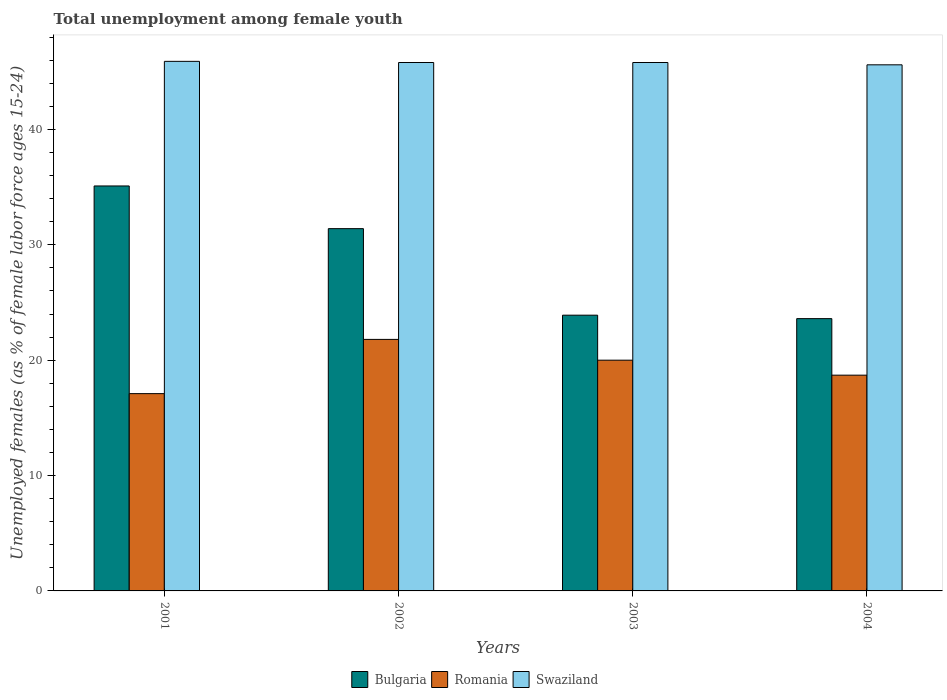How many different coloured bars are there?
Your answer should be very brief. 3. Are the number of bars per tick equal to the number of legend labels?
Offer a terse response. Yes. Are the number of bars on each tick of the X-axis equal?
Make the answer very short. Yes. How many bars are there on the 2nd tick from the left?
Your answer should be very brief. 3. How many bars are there on the 4th tick from the right?
Offer a terse response. 3. In how many cases, is the number of bars for a given year not equal to the number of legend labels?
Make the answer very short. 0. What is the percentage of unemployed females in in Swaziland in 2003?
Your response must be concise. 45.8. Across all years, what is the maximum percentage of unemployed females in in Swaziland?
Keep it short and to the point. 45.9. Across all years, what is the minimum percentage of unemployed females in in Romania?
Your answer should be compact. 17.1. In which year was the percentage of unemployed females in in Bulgaria minimum?
Make the answer very short. 2004. What is the total percentage of unemployed females in in Romania in the graph?
Keep it short and to the point. 77.6. What is the difference between the percentage of unemployed females in in Romania in 2003 and the percentage of unemployed females in in Swaziland in 2001?
Your response must be concise. -25.9. What is the average percentage of unemployed females in in Swaziland per year?
Your answer should be very brief. 45.77. In the year 2004, what is the difference between the percentage of unemployed females in in Swaziland and percentage of unemployed females in in Romania?
Give a very brief answer. 26.9. What is the ratio of the percentage of unemployed females in in Romania in 2001 to that in 2004?
Your response must be concise. 0.91. Is the percentage of unemployed females in in Romania in 2002 less than that in 2004?
Offer a very short reply. No. Is the difference between the percentage of unemployed females in in Swaziland in 2003 and 2004 greater than the difference between the percentage of unemployed females in in Romania in 2003 and 2004?
Provide a succinct answer. No. What is the difference between the highest and the second highest percentage of unemployed females in in Romania?
Give a very brief answer. 1.8. What is the difference between the highest and the lowest percentage of unemployed females in in Bulgaria?
Keep it short and to the point. 11.5. What does the 2nd bar from the left in 2003 represents?
Your response must be concise. Romania. What does the 3rd bar from the right in 2003 represents?
Provide a succinct answer. Bulgaria. Is it the case that in every year, the sum of the percentage of unemployed females in in Swaziland and percentage of unemployed females in in Romania is greater than the percentage of unemployed females in in Bulgaria?
Provide a short and direct response. Yes. How many bars are there?
Your response must be concise. 12. How many years are there in the graph?
Give a very brief answer. 4. Does the graph contain any zero values?
Your answer should be compact. No. Does the graph contain grids?
Make the answer very short. No. How many legend labels are there?
Provide a short and direct response. 3. What is the title of the graph?
Provide a succinct answer. Total unemployment among female youth. What is the label or title of the X-axis?
Offer a terse response. Years. What is the label or title of the Y-axis?
Make the answer very short. Unemployed females (as % of female labor force ages 15-24). What is the Unemployed females (as % of female labor force ages 15-24) of Bulgaria in 2001?
Keep it short and to the point. 35.1. What is the Unemployed females (as % of female labor force ages 15-24) of Romania in 2001?
Give a very brief answer. 17.1. What is the Unemployed females (as % of female labor force ages 15-24) in Swaziland in 2001?
Give a very brief answer. 45.9. What is the Unemployed females (as % of female labor force ages 15-24) of Bulgaria in 2002?
Make the answer very short. 31.4. What is the Unemployed females (as % of female labor force ages 15-24) of Romania in 2002?
Your answer should be very brief. 21.8. What is the Unemployed females (as % of female labor force ages 15-24) of Swaziland in 2002?
Ensure brevity in your answer.  45.8. What is the Unemployed females (as % of female labor force ages 15-24) in Bulgaria in 2003?
Your response must be concise. 23.9. What is the Unemployed females (as % of female labor force ages 15-24) of Swaziland in 2003?
Your response must be concise. 45.8. What is the Unemployed females (as % of female labor force ages 15-24) in Bulgaria in 2004?
Offer a very short reply. 23.6. What is the Unemployed females (as % of female labor force ages 15-24) of Romania in 2004?
Offer a very short reply. 18.7. What is the Unemployed females (as % of female labor force ages 15-24) of Swaziland in 2004?
Provide a succinct answer. 45.6. Across all years, what is the maximum Unemployed females (as % of female labor force ages 15-24) in Bulgaria?
Provide a short and direct response. 35.1. Across all years, what is the maximum Unemployed females (as % of female labor force ages 15-24) of Romania?
Provide a succinct answer. 21.8. Across all years, what is the maximum Unemployed females (as % of female labor force ages 15-24) in Swaziland?
Make the answer very short. 45.9. Across all years, what is the minimum Unemployed females (as % of female labor force ages 15-24) of Bulgaria?
Make the answer very short. 23.6. Across all years, what is the minimum Unemployed females (as % of female labor force ages 15-24) in Romania?
Provide a short and direct response. 17.1. Across all years, what is the minimum Unemployed females (as % of female labor force ages 15-24) in Swaziland?
Make the answer very short. 45.6. What is the total Unemployed females (as % of female labor force ages 15-24) of Bulgaria in the graph?
Offer a very short reply. 114. What is the total Unemployed females (as % of female labor force ages 15-24) in Romania in the graph?
Keep it short and to the point. 77.6. What is the total Unemployed females (as % of female labor force ages 15-24) of Swaziland in the graph?
Your response must be concise. 183.1. What is the difference between the Unemployed females (as % of female labor force ages 15-24) in Bulgaria in 2001 and that in 2002?
Provide a short and direct response. 3.7. What is the difference between the Unemployed females (as % of female labor force ages 15-24) of Romania in 2001 and that in 2002?
Your answer should be compact. -4.7. What is the difference between the Unemployed females (as % of female labor force ages 15-24) of Romania in 2001 and that in 2003?
Your response must be concise. -2.9. What is the difference between the Unemployed females (as % of female labor force ages 15-24) of Bulgaria in 2001 and that in 2004?
Give a very brief answer. 11.5. What is the difference between the Unemployed females (as % of female labor force ages 15-24) in Romania in 2001 and that in 2004?
Your response must be concise. -1.6. What is the difference between the Unemployed females (as % of female labor force ages 15-24) of Swaziland in 2002 and that in 2003?
Your answer should be compact. 0. What is the difference between the Unemployed females (as % of female labor force ages 15-24) of Bulgaria in 2002 and that in 2004?
Ensure brevity in your answer.  7.8. What is the difference between the Unemployed females (as % of female labor force ages 15-24) of Bulgaria in 2003 and that in 2004?
Give a very brief answer. 0.3. What is the difference between the Unemployed females (as % of female labor force ages 15-24) in Romania in 2001 and the Unemployed females (as % of female labor force ages 15-24) in Swaziland in 2002?
Your answer should be very brief. -28.7. What is the difference between the Unemployed females (as % of female labor force ages 15-24) in Bulgaria in 2001 and the Unemployed females (as % of female labor force ages 15-24) in Romania in 2003?
Your answer should be very brief. 15.1. What is the difference between the Unemployed females (as % of female labor force ages 15-24) in Bulgaria in 2001 and the Unemployed females (as % of female labor force ages 15-24) in Swaziland in 2003?
Your answer should be compact. -10.7. What is the difference between the Unemployed females (as % of female labor force ages 15-24) of Romania in 2001 and the Unemployed females (as % of female labor force ages 15-24) of Swaziland in 2003?
Your answer should be very brief. -28.7. What is the difference between the Unemployed females (as % of female labor force ages 15-24) in Bulgaria in 2001 and the Unemployed females (as % of female labor force ages 15-24) in Romania in 2004?
Offer a terse response. 16.4. What is the difference between the Unemployed females (as % of female labor force ages 15-24) of Romania in 2001 and the Unemployed females (as % of female labor force ages 15-24) of Swaziland in 2004?
Your response must be concise. -28.5. What is the difference between the Unemployed females (as % of female labor force ages 15-24) in Bulgaria in 2002 and the Unemployed females (as % of female labor force ages 15-24) in Romania in 2003?
Offer a very short reply. 11.4. What is the difference between the Unemployed females (as % of female labor force ages 15-24) of Bulgaria in 2002 and the Unemployed females (as % of female labor force ages 15-24) of Swaziland in 2003?
Offer a very short reply. -14.4. What is the difference between the Unemployed females (as % of female labor force ages 15-24) in Bulgaria in 2002 and the Unemployed females (as % of female labor force ages 15-24) in Romania in 2004?
Ensure brevity in your answer.  12.7. What is the difference between the Unemployed females (as % of female labor force ages 15-24) of Bulgaria in 2002 and the Unemployed females (as % of female labor force ages 15-24) of Swaziland in 2004?
Make the answer very short. -14.2. What is the difference between the Unemployed females (as % of female labor force ages 15-24) of Romania in 2002 and the Unemployed females (as % of female labor force ages 15-24) of Swaziland in 2004?
Your response must be concise. -23.8. What is the difference between the Unemployed females (as % of female labor force ages 15-24) of Bulgaria in 2003 and the Unemployed females (as % of female labor force ages 15-24) of Romania in 2004?
Your response must be concise. 5.2. What is the difference between the Unemployed females (as % of female labor force ages 15-24) of Bulgaria in 2003 and the Unemployed females (as % of female labor force ages 15-24) of Swaziland in 2004?
Offer a terse response. -21.7. What is the difference between the Unemployed females (as % of female labor force ages 15-24) of Romania in 2003 and the Unemployed females (as % of female labor force ages 15-24) of Swaziland in 2004?
Provide a short and direct response. -25.6. What is the average Unemployed females (as % of female labor force ages 15-24) of Romania per year?
Ensure brevity in your answer.  19.4. What is the average Unemployed females (as % of female labor force ages 15-24) of Swaziland per year?
Offer a very short reply. 45.77. In the year 2001, what is the difference between the Unemployed females (as % of female labor force ages 15-24) in Romania and Unemployed females (as % of female labor force ages 15-24) in Swaziland?
Your answer should be compact. -28.8. In the year 2002, what is the difference between the Unemployed females (as % of female labor force ages 15-24) of Bulgaria and Unemployed females (as % of female labor force ages 15-24) of Swaziland?
Offer a terse response. -14.4. In the year 2002, what is the difference between the Unemployed females (as % of female labor force ages 15-24) in Romania and Unemployed females (as % of female labor force ages 15-24) in Swaziland?
Give a very brief answer. -24. In the year 2003, what is the difference between the Unemployed females (as % of female labor force ages 15-24) in Bulgaria and Unemployed females (as % of female labor force ages 15-24) in Romania?
Keep it short and to the point. 3.9. In the year 2003, what is the difference between the Unemployed females (as % of female labor force ages 15-24) of Bulgaria and Unemployed females (as % of female labor force ages 15-24) of Swaziland?
Ensure brevity in your answer.  -21.9. In the year 2003, what is the difference between the Unemployed females (as % of female labor force ages 15-24) of Romania and Unemployed females (as % of female labor force ages 15-24) of Swaziland?
Ensure brevity in your answer.  -25.8. In the year 2004, what is the difference between the Unemployed females (as % of female labor force ages 15-24) of Bulgaria and Unemployed females (as % of female labor force ages 15-24) of Romania?
Offer a very short reply. 4.9. In the year 2004, what is the difference between the Unemployed females (as % of female labor force ages 15-24) in Romania and Unemployed females (as % of female labor force ages 15-24) in Swaziland?
Your response must be concise. -26.9. What is the ratio of the Unemployed females (as % of female labor force ages 15-24) in Bulgaria in 2001 to that in 2002?
Make the answer very short. 1.12. What is the ratio of the Unemployed females (as % of female labor force ages 15-24) in Romania in 2001 to that in 2002?
Make the answer very short. 0.78. What is the ratio of the Unemployed females (as % of female labor force ages 15-24) in Bulgaria in 2001 to that in 2003?
Provide a short and direct response. 1.47. What is the ratio of the Unemployed females (as % of female labor force ages 15-24) in Romania in 2001 to that in 2003?
Your answer should be very brief. 0.85. What is the ratio of the Unemployed females (as % of female labor force ages 15-24) in Swaziland in 2001 to that in 2003?
Provide a succinct answer. 1. What is the ratio of the Unemployed females (as % of female labor force ages 15-24) in Bulgaria in 2001 to that in 2004?
Provide a short and direct response. 1.49. What is the ratio of the Unemployed females (as % of female labor force ages 15-24) of Romania in 2001 to that in 2004?
Give a very brief answer. 0.91. What is the ratio of the Unemployed females (as % of female labor force ages 15-24) in Swaziland in 2001 to that in 2004?
Offer a terse response. 1.01. What is the ratio of the Unemployed females (as % of female labor force ages 15-24) in Bulgaria in 2002 to that in 2003?
Your answer should be compact. 1.31. What is the ratio of the Unemployed females (as % of female labor force ages 15-24) of Romania in 2002 to that in 2003?
Give a very brief answer. 1.09. What is the ratio of the Unemployed females (as % of female labor force ages 15-24) in Swaziland in 2002 to that in 2003?
Provide a short and direct response. 1. What is the ratio of the Unemployed females (as % of female labor force ages 15-24) in Bulgaria in 2002 to that in 2004?
Offer a very short reply. 1.33. What is the ratio of the Unemployed females (as % of female labor force ages 15-24) of Romania in 2002 to that in 2004?
Offer a very short reply. 1.17. What is the ratio of the Unemployed females (as % of female labor force ages 15-24) of Swaziland in 2002 to that in 2004?
Give a very brief answer. 1. What is the ratio of the Unemployed females (as % of female labor force ages 15-24) in Bulgaria in 2003 to that in 2004?
Offer a terse response. 1.01. What is the ratio of the Unemployed females (as % of female labor force ages 15-24) of Romania in 2003 to that in 2004?
Keep it short and to the point. 1.07. What is the ratio of the Unemployed females (as % of female labor force ages 15-24) in Swaziland in 2003 to that in 2004?
Your response must be concise. 1. What is the difference between the highest and the second highest Unemployed females (as % of female labor force ages 15-24) of Bulgaria?
Your response must be concise. 3.7. What is the difference between the highest and the second highest Unemployed females (as % of female labor force ages 15-24) of Romania?
Give a very brief answer. 1.8. What is the difference between the highest and the second highest Unemployed females (as % of female labor force ages 15-24) of Swaziland?
Your answer should be very brief. 0.1. 